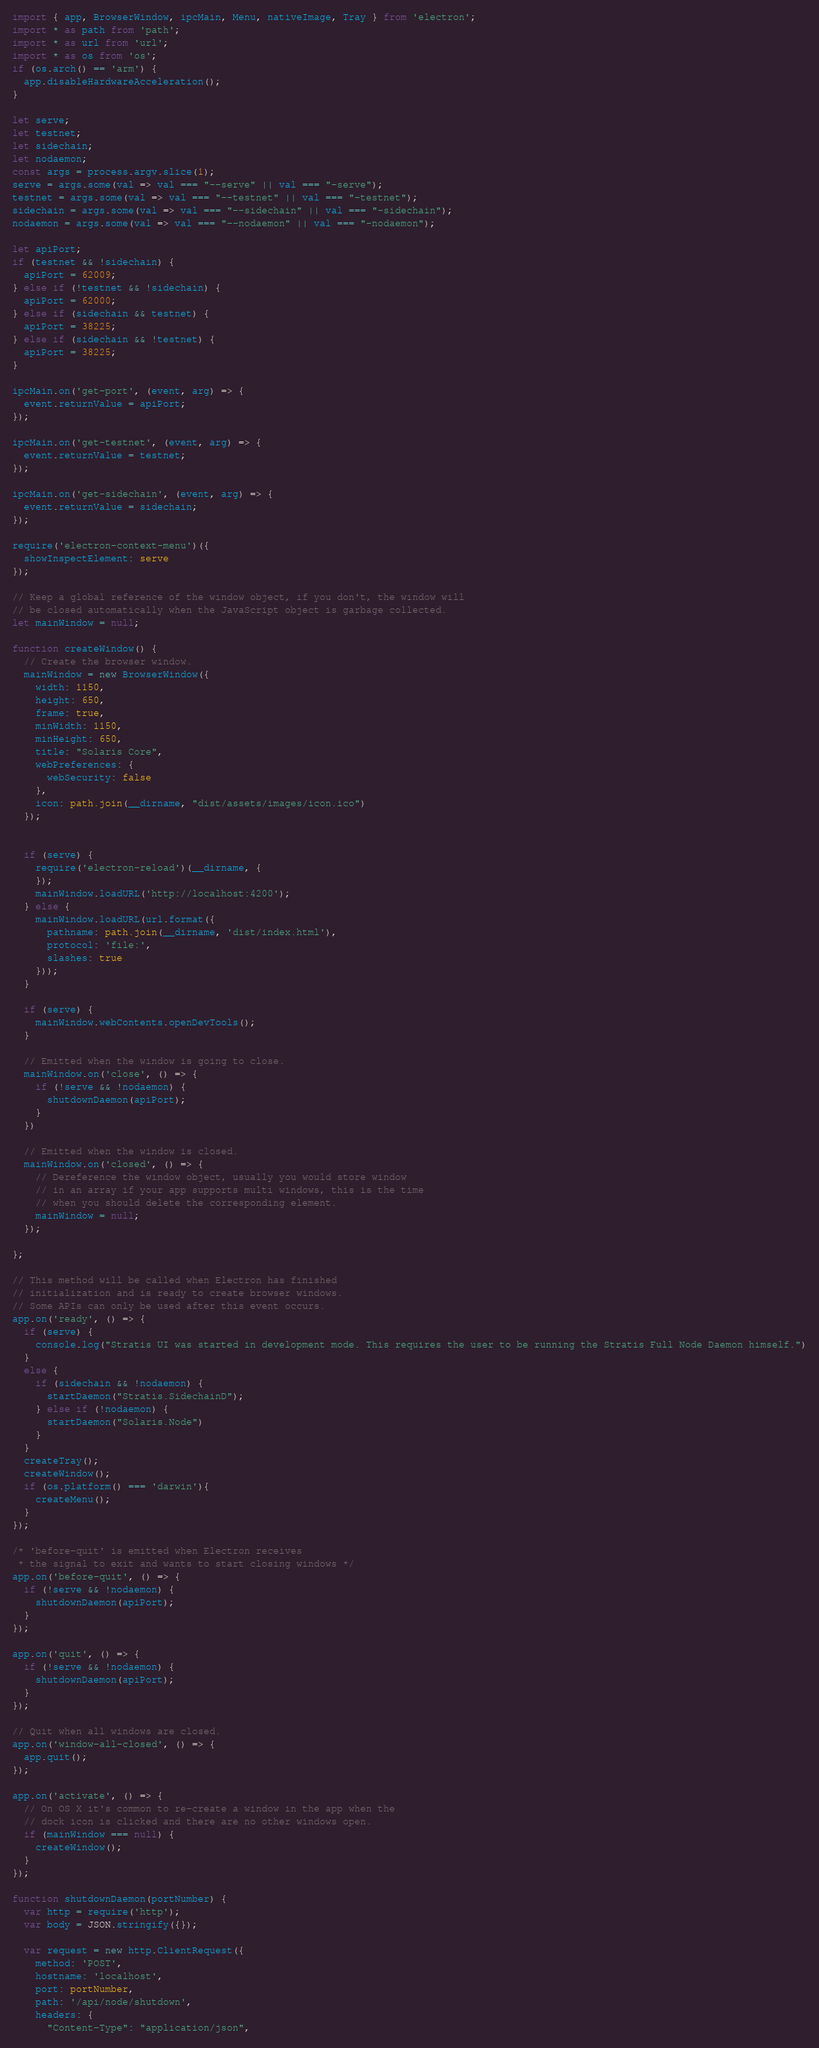<code> <loc_0><loc_0><loc_500><loc_500><_TypeScript_>import { app, BrowserWindow, ipcMain, Menu, nativeImage, Tray } from 'electron';
import * as path from 'path';
import * as url from 'url';
import * as os from 'os';
if (os.arch() == 'arm') {
  app.disableHardwareAcceleration();
}

let serve;
let testnet;
let sidechain;
let nodaemon;
const args = process.argv.slice(1);
serve = args.some(val => val === "--serve" || val === "-serve");
testnet = args.some(val => val === "--testnet" || val === "-testnet");
sidechain = args.some(val => val === "--sidechain" || val === "-sidechain");
nodaemon = args.some(val => val === "--nodaemon" || val === "-nodaemon");

let apiPort;
if (testnet && !sidechain) {
  apiPort = 62009;
} else if (!testnet && !sidechain) {
  apiPort = 62000;
} else if (sidechain && testnet) {
  apiPort = 38225;
} else if (sidechain && !testnet) {
  apiPort = 38225;
}

ipcMain.on('get-port', (event, arg) => {
  event.returnValue = apiPort;
});

ipcMain.on('get-testnet', (event, arg) => {
  event.returnValue = testnet;
});

ipcMain.on('get-sidechain', (event, arg) => {
  event.returnValue = sidechain;
});

require('electron-context-menu')({
  showInspectElement: serve
});

// Keep a global reference of the window object, if you don't, the window will
// be closed automatically when the JavaScript object is garbage collected.
let mainWindow = null;

function createWindow() {
  // Create the browser window.
  mainWindow = new BrowserWindow({
    width: 1150,
    height: 650,
    frame: true,
    minWidth: 1150,
    minHeight: 650,
    title: "Solaris Core",
    webPreferences: {
      webSecurity: false
    },
    icon: path.join(__dirname, "dist/assets/images/icon.ico")
  });

  
  if (serve) {
    require('electron-reload')(__dirname, {
    });
    mainWindow.loadURL('http://localhost:4200');
  } else {
    mainWindow.loadURL(url.format({
      pathname: path.join(__dirname, 'dist/index.html'),
      protocol: 'file:',
      slashes: true
    }));
  }

  if (serve) {
    mainWindow.webContents.openDevTools();
  }

  // Emitted when the window is going to close.
  mainWindow.on('close', () => {
    if (!serve && !nodaemon) {
      shutdownDaemon(apiPort);
    }
  })

  // Emitted when the window is closed.
  mainWindow.on('closed', () => {
    // Dereference the window object, usually you would store window
    // in an array if your app supports multi windows, this is the time
    // when you should delete the corresponding element.
    mainWindow = null;
  });

};

// This method will be called when Electron has finished
// initialization and is ready to create browser windows.
// Some APIs can only be used after this event occurs.
app.on('ready', () => {
  if (serve) {
    console.log("Stratis UI was started in development mode. This requires the user to be running the Stratis Full Node Daemon himself.")
  }
  else {
    if (sidechain && !nodaemon) {
      startDaemon("Stratis.SidechainD");
    } else if (!nodaemon) {
      startDaemon("Solaris.Node")
    }
  }
  createTray();
  createWindow();
  if (os.platform() === 'darwin'){
    createMenu();
  }
});

/* 'before-quit' is emitted when Electron receives
 * the signal to exit and wants to start closing windows */
app.on('before-quit', () => {
  if (!serve && !nodaemon) {
    shutdownDaemon(apiPort);
  }
});

app.on('quit', () => {
  if (!serve && !nodaemon) {
    shutdownDaemon(apiPort);
  }
});

// Quit when all windows are closed.
app.on('window-all-closed', () => {
  app.quit();
});

app.on('activate', () => {
  // On OS X it's common to re-create a window in the app when the
  // dock icon is clicked and there are no other windows open.
  if (mainWindow === null) {
    createWindow();
  }
});

function shutdownDaemon(portNumber) {
  var http = require('http');
  var body = JSON.stringify({});

  var request = new http.ClientRequest({
    method: 'POST',
    hostname: 'localhost',
    port: portNumber,
    path: '/api/node/shutdown',
    headers: {
      "Content-Type": "application/json",</code> 